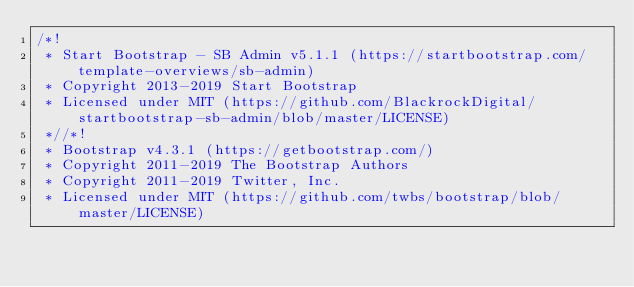<code> <loc_0><loc_0><loc_500><loc_500><_CSS_>/*!
 * Start Bootstrap - SB Admin v5.1.1 (https://startbootstrap.com/template-overviews/sb-admin)
 * Copyright 2013-2019 Start Bootstrap
 * Licensed under MIT (https://github.com/BlackrockDigital/startbootstrap-sb-admin/blob/master/LICENSE)
 *//*!
 * Bootstrap v4.3.1 (https://getbootstrap.com/)
 * Copyright 2011-2019 The Bootstrap Authors
 * Copyright 2011-2019 Twitter, Inc.
 * Licensed under MIT (https://github.com/twbs/bootstrap/blob/master/LICENSE)</code> 